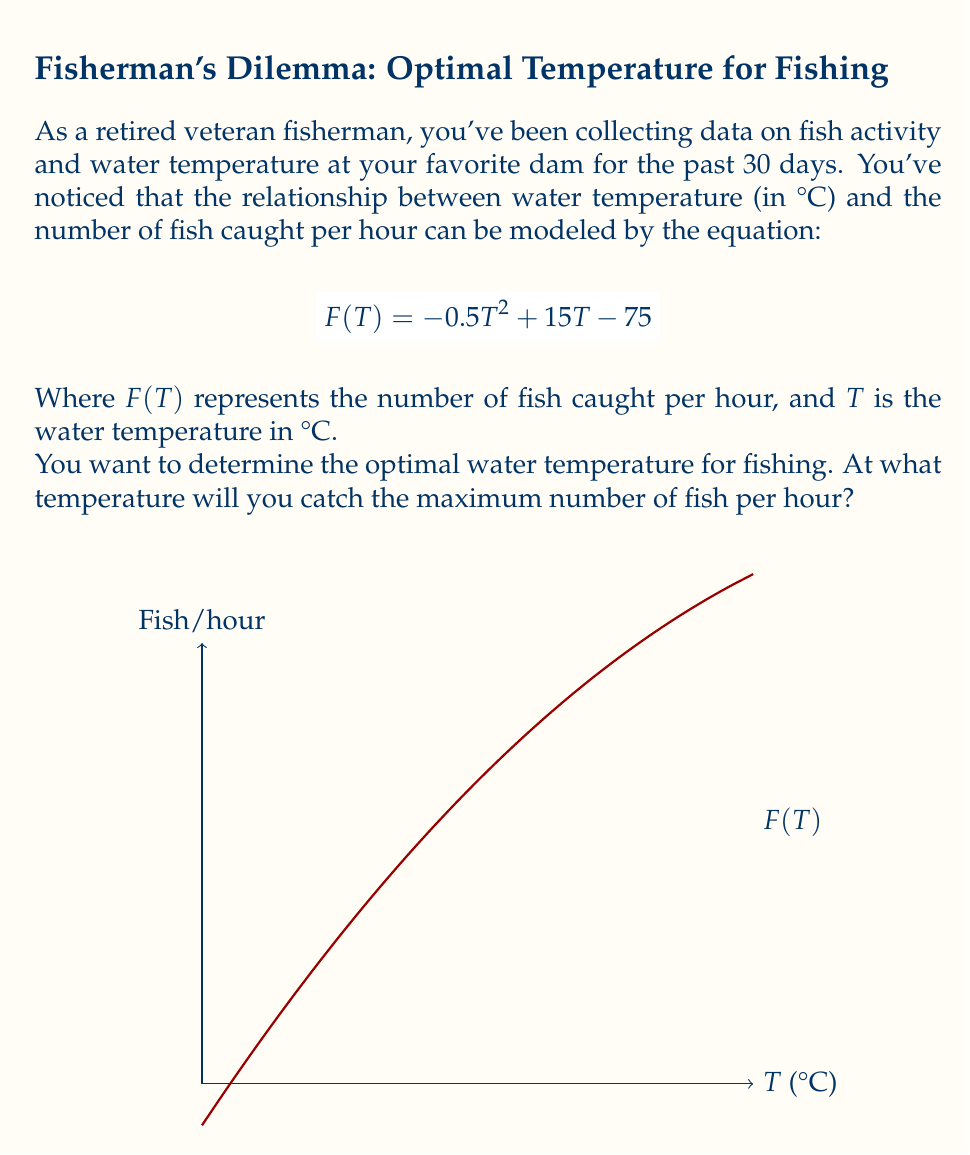Show me your answer to this math problem. Let's approach this step-by-step:

1) The function $F(T) = -0.5T^2 + 15T - 75$ is a quadratic function, which forms a parabola when graphed.

2) To find the maximum value of a quadratic function, we need to find the vertex of the parabola. The T-coordinate of the vertex will give us the optimal temperature.

3) For a quadratic function in the form $f(x) = ax^2 + bx + c$, the x-coordinate of the vertex is given by $x = -\frac{b}{2a}$.

4) In our case, $a = -0.5$, $b = 15$, and $c = -75$.

5) Substituting these values into the formula:

   $$T = -\frac{15}{2(-0.5)} = -\frac{15}{-1} = 15$$

6) Therefore, the optimal temperature is 15°C.

7) We can verify this by testing temperatures slightly above and below 15°C:
   
   $F(14) = -0.5(14)^2 + 15(14) - 75 = 37$
   $F(15) = -0.5(15)^2 + 15(15) - 75 = 37.5$
   $F(16) = -0.5(16)^2 + 15(16) - 75 = 37$

   This confirms that 15°C gives the maximum value.
Answer: 15°C 